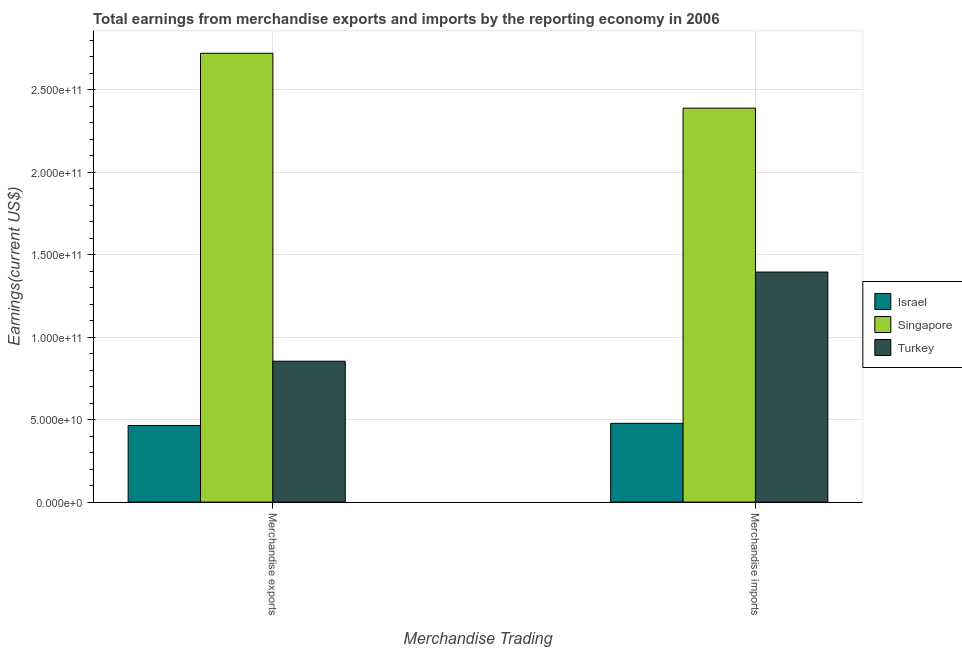How many different coloured bars are there?
Offer a terse response. 3. Are the number of bars on each tick of the X-axis equal?
Provide a succinct answer. Yes. How many bars are there on the 1st tick from the left?
Give a very brief answer. 3. What is the earnings from merchandise imports in Singapore?
Make the answer very short. 2.39e+11. Across all countries, what is the maximum earnings from merchandise imports?
Ensure brevity in your answer.  2.39e+11. Across all countries, what is the minimum earnings from merchandise exports?
Provide a succinct answer. 4.64e+1. In which country was the earnings from merchandise exports maximum?
Ensure brevity in your answer.  Singapore. In which country was the earnings from merchandise imports minimum?
Ensure brevity in your answer.  Israel. What is the total earnings from merchandise imports in the graph?
Make the answer very short. 4.26e+11. What is the difference between the earnings from merchandise exports in Singapore and that in Turkey?
Make the answer very short. 1.87e+11. What is the difference between the earnings from merchandise imports in Israel and the earnings from merchandise exports in Singapore?
Give a very brief answer. -2.24e+11. What is the average earnings from merchandise exports per country?
Provide a short and direct response. 1.35e+11. What is the difference between the earnings from merchandise exports and earnings from merchandise imports in Turkey?
Give a very brief answer. -5.40e+1. In how many countries, is the earnings from merchandise exports greater than 150000000000 US$?
Provide a short and direct response. 1. What is the ratio of the earnings from merchandise imports in Singapore to that in Israel?
Offer a terse response. 5. Is the earnings from merchandise imports in Singapore less than that in Turkey?
Ensure brevity in your answer.  No. In how many countries, is the earnings from merchandise imports greater than the average earnings from merchandise imports taken over all countries?
Provide a succinct answer. 1. What does the 1st bar from the right in Merchandise exports represents?
Ensure brevity in your answer.  Turkey. Are all the bars in the graph horizontal?
Offer a terse response. No. What is the difference between two consecutive major ticks on the Y-axis?
Keep it short and to the point. 5.00e+1. Where does the legend appear in the graph?
Your answer should be very brief. Center right. How are the legend labels stacked?
Your response must be concise. Vertical. What is the title of the graph?
Give a very brief answer. Total earnings from merchandise exports and imports by the reporting economy in 2006. Does "Fiji" appear as one of the legend labels in the graph?
Offer a terse response. No. What is the label or title of the X-axis?
Your answer should be very brief. Merchandise Trading. What is the label or title of the Y-axis?
Give a very brief answer. Earnings(current US$). What is the Earnings(current US$) of Israel in Merchandise exports?
Offer a terse response. 4.64e+1. What is the Earnings(current US$) of Singapore in Merchandise exports?
Your answer should be very brief. 2.72e+11. What is the Earnings(current US$) in Turkey in Merchandise exports?
Provide a short and direct response. 8.54e+1. What is the Earnings(current US$) in Israel in Merchandise imports?
Your response must be concise. 4.77e+1. What is the Earnings(current US$) in Singapore in Merchandise imports?
Ensure brevity in your answer.  2.39e+11. What is the Earnings(current US$) in Turkey in Merchandise imports?
Make the answer very short. 1.39e+11. Across all Merchandise Trading, what is the maximum Earnings(current US$) in Israel?
Provide a short and direct response. 4.77e+1. Across all Merchandise Trading, what is the maximum Earnings(current US$) in Singapore?
Provide a succinct answer. 2.72e+11. Across all Merchandise Trading, what is the maximum Earnings(current US$) of Turkey?
Offer a very short reply. 1.39e+11. Across all Merchandise Trading, what is the minimum Earnings(current US$) in Israel?
Offer a very short reply. 4.64e+1. Across all Merchandise Trading, what is the minimum Earnings(current US$) in Singapore?
Your response must be concise. 2.39e+11. Across all Merchandise Trading, what is the minimum Earnings(current US$) in Turkey?
Your answer should be compact. 8.54e+1. What is the total Earnings(current US$) of Israel in the graph?
Your response must be concise. 9.42e+1. What is the total Earnings(current US$) of Singapore in the graph?
Offer a terse response. 5.11e+11. What is the total Earnings(current US$) of Turkey in the graph?
Your answer should be very brief. 2.25e+11. What is the difference between the Earnings(current US$) of Israel in Merchandise exports and that in Merchandise imports?
Offer a terse response. -1.31e+09. What is the difference between the Earnings(current US$) of Singapore in Merchandise exports and that in Merchandise imports?
Offer a terse response. 3.33e+1. What is the difference between the Earnings(current US$) in Turkey in Merchandise exports and that in Merchandise imports?
Make the answer very short. -5.40e+1. What is the difference between the Earnings(current US$) in Israel in Merchandise exports and the Earnings(current US$) in Singapore in Merchandise imports?
Your answer should be very brief. -1.92e+11. What is the difference between the Earnings(current US$) of Israel in Merchandise exports and the Earnings(current US$) of Turkey in Merchandise imports?
Your answer should be very brief. -9.30e+1. What is the difference between the Earnings(current US$) of Singapore in Merchandise exports and the Earnings(current US$) of Turkey in Merchandise imports?
Give a very brief answer. 1.33e+11. What is the average Earnings(current US$) of Israel per Merchandise Trading?
Keep it short and to the point. 4.71e+1. What is the average Earnings(current US$) of Singapore per Merchandise Trading?
Your answer should be very brief. 2.55e+11. What is the average Earnings(current US$) in Turkey per Merchandise Trading?
Your response must be concise. 1.12e+11. What is the difference between the Earnings(current US$) in Israel and Earnings(current US$) in Singapore in Merchandise exports?
Offer a terse response. -2.26e+11. What is the difference between the Earnings(current US$) in Israel and Earnings(current US$) in Turkey in Merchandise exports?
Your response must be concise. -3.90e+1. What is the difference between the Earnings(current US$) of Singapore and Earnings(current US$) of Turkey in Merchandise exports?
Offer a terse response. 1.87e+11. What is the difference between the Earnings(current US$) of Israel and Earnings(current US$) of Singapore in Merchandise imports?
Your answer should be very brief. -1.91e+11. What is the difference between the Earnings(current US$) in Israel and Earnings(current US$) in Turkey in Merchandise imports?
Provide a short and direct response. -9.17e+1. What is the difference between the Earnings(current US$) in Singapore and Earnings(current US$) in Turkey in Merchandise imports?
Provide a short and direct response. 9.93e+1. What is the ratio of the Earnings(current US$) of Israel in Merchandise exports to that in Merchandise imports?
Keep it short and to the point. 0.97. What is the ratio of the Earnings(current US$) of Singapore in Merchandise exports to that in Merchandise imports?
Offer a very short reply. 1.14. What is the ratio of the Earnings(current US$) of Turkey in Merchandise exports to that in Merchandise imports?
Your response must be concise. 0.61. What is the difference between the highest and the second highest Earnings(current US$) of Israel?
Make the answer very short. 1.31e+09. What is the difference between the highest and the second highest Earnings(current US$) in Singapore?
Offer a terse response. 3.33e+1. What is the difference between the highest and the second highest Earnings(current US$) of Turkey?
Offer a terse response. 5.40e+1. What is the difference between the highest and the lowest Earnings(current US$) in Israel?
Your answer should be compact. 1.31e+09. What is the difference between the highest and the lowest Earnings(current US$) of Singapore?
Offer a very short reply. 3.33e+1. What is the difference between the highest and the lowest Earnings(current US$) of Turkey?
Ensure brevity in your answer.  5.40e+1. 